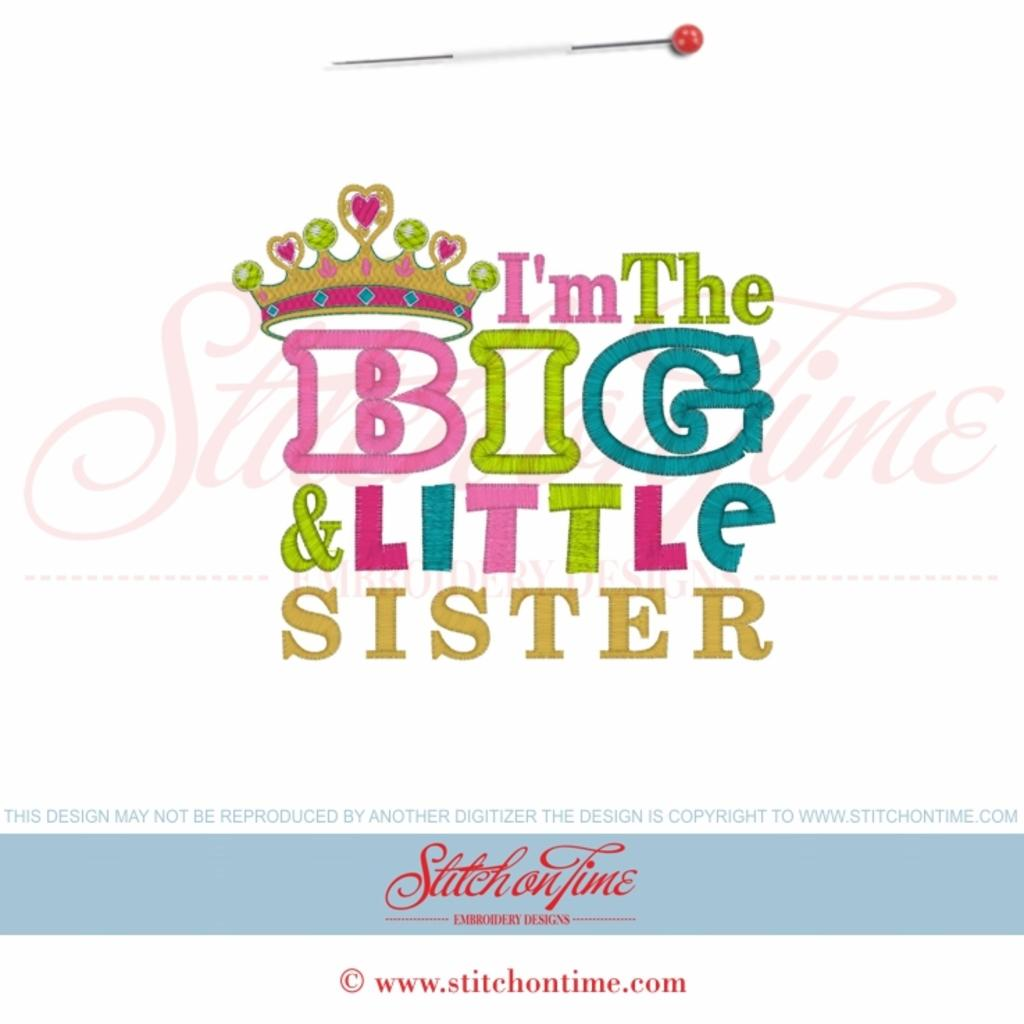What can be seen in the image? There is a poster in the image. What is featured on the poster? There is text written on the poster. How many houses are depicted on the poster? There are no houses depicted on the poster; it only features text. What trick is being used to draw attention to the poster? There is no trick mentioned or depicted in the image; it simply contains a poster with text. 